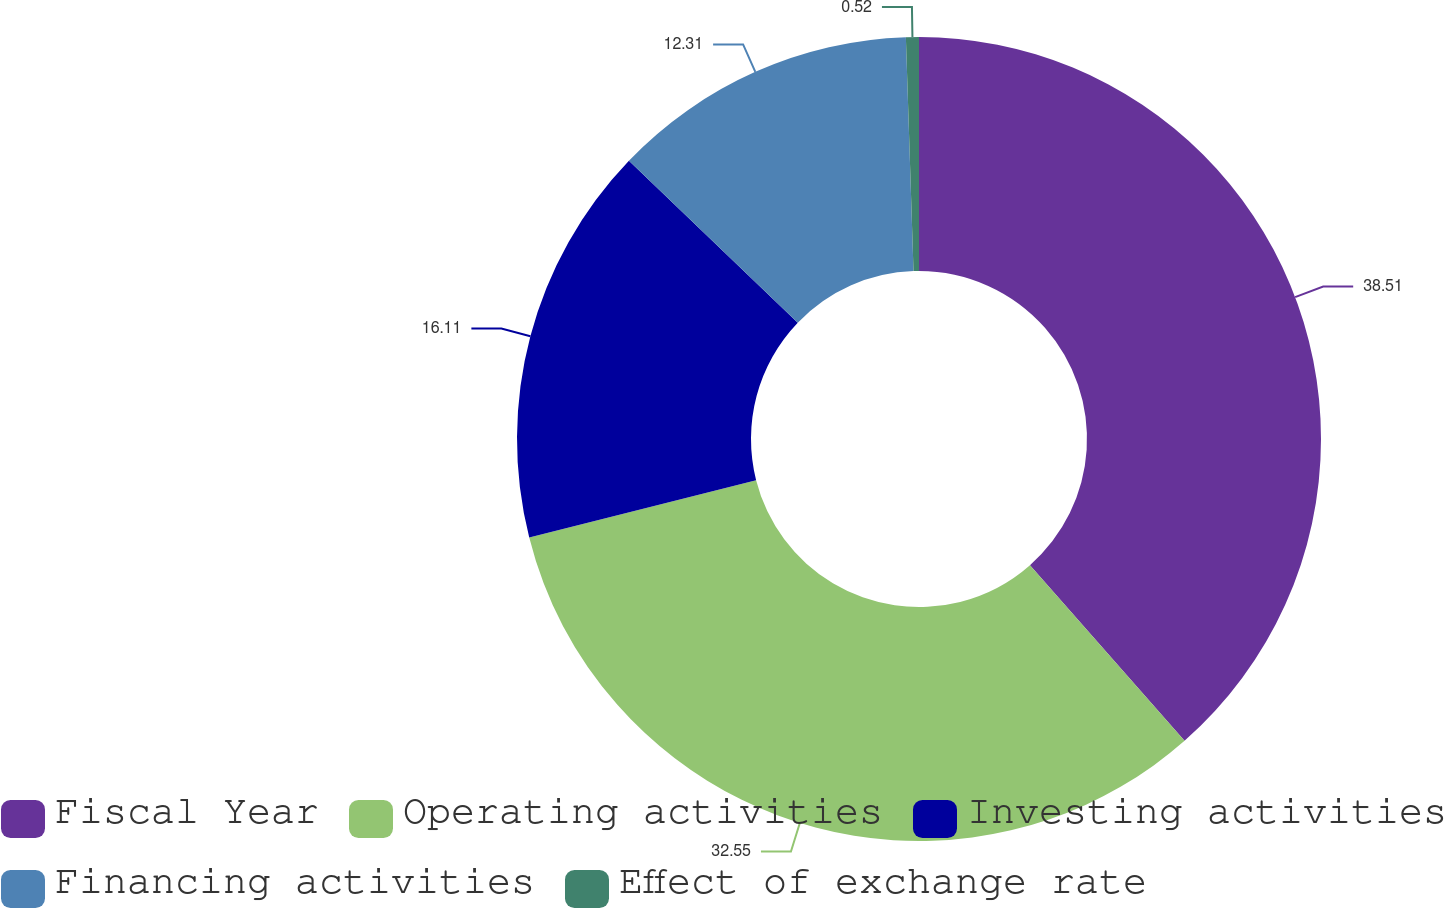Convert chart. <chart><loc_0><loc_0><loc_500><loc_500><pie_chart><fcel>Fiscal Year<fcel>Operating activities<fcel>Investing activities<fcel>Financing activities<fcel>Effect of exchange rate<nl><fcel>38.52%<fcel>32.55%<fcel>16.11%<fcel>12.31%<fcel>0.52%<nl></chart> 